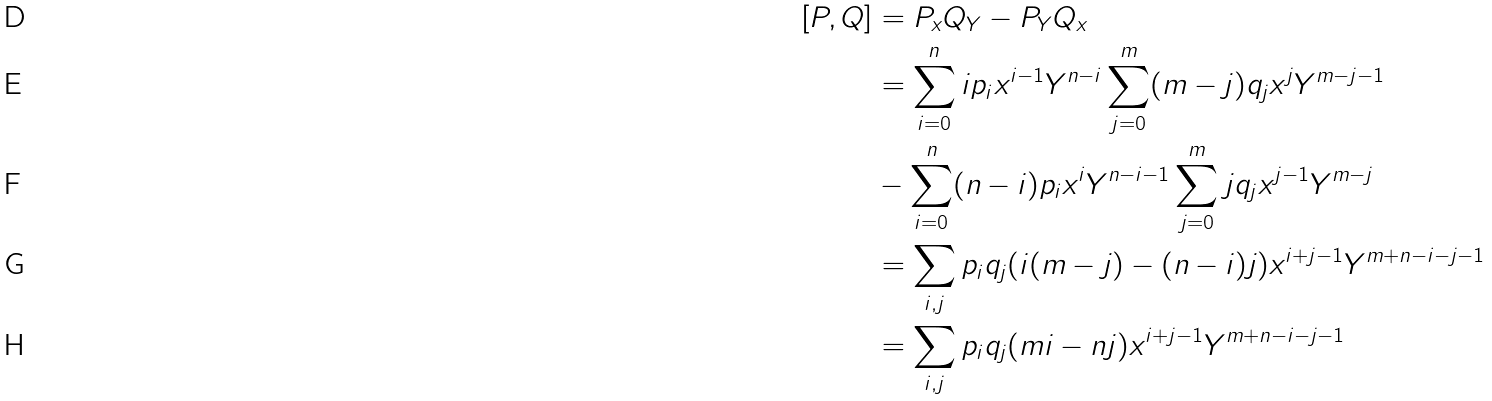Convert formula to latex. <formula><loc_0><loc_0><loc_500><loc_500>[ P , Q ] & = P _ { x } Q _ { Y } - P _ { Y } Q _ { x } \\ & = \sum _ { i = 0 } ^ { n } i p _ { i } x ^ { i - 1 } Y ^ { n - i } \sum _ { j = 0 } ^ { m } ( m - j ) q _ { j } x ^ { j } Y ^ { m - j - 1 } \\ & - \sum _ { i = 0 } ^ { n } ( n - i ) p _ { i } x ^ { i } Y ^ { n - i - 1 } \sum _ { j = 0 } ^ { m } j q _ { j } x ^ { j - 1 } Y ^ { m - j } \\ & = \sum _ { i , j } p _ { i } q _ { j } ( i ( m - j ) - ( n - i ) j ) x ^ { i + j - 1 } Y ^ { m + n - i - j - 1 } \\ & = \sum _ { i , j } p _ { i } q _ { j } ( m i - n j ) x ^ { i + j - 1 } Y ^ { m + n - i - j - 1 }</formula> 